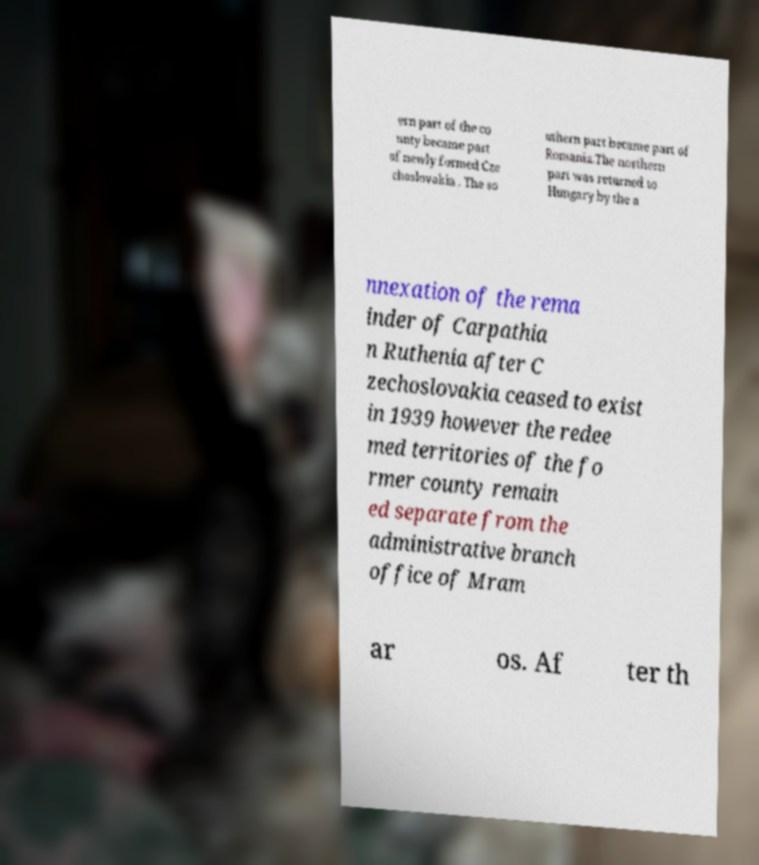Could you assist in decoding the text presented in this image and type it out clearly? ern part of the co unty became part of newly formed Cze choslovakia . The so uthern part became part of Romania.The northern part was returned to Hungary by the a nnexation of the rema inder of Carpathia n Ruthenia after C zechoslovakia ceased to exist in 1939 however the redee med territories of the fo rmer county remain ed separate from the administrative branch office of Mram ar os. Af ter th 